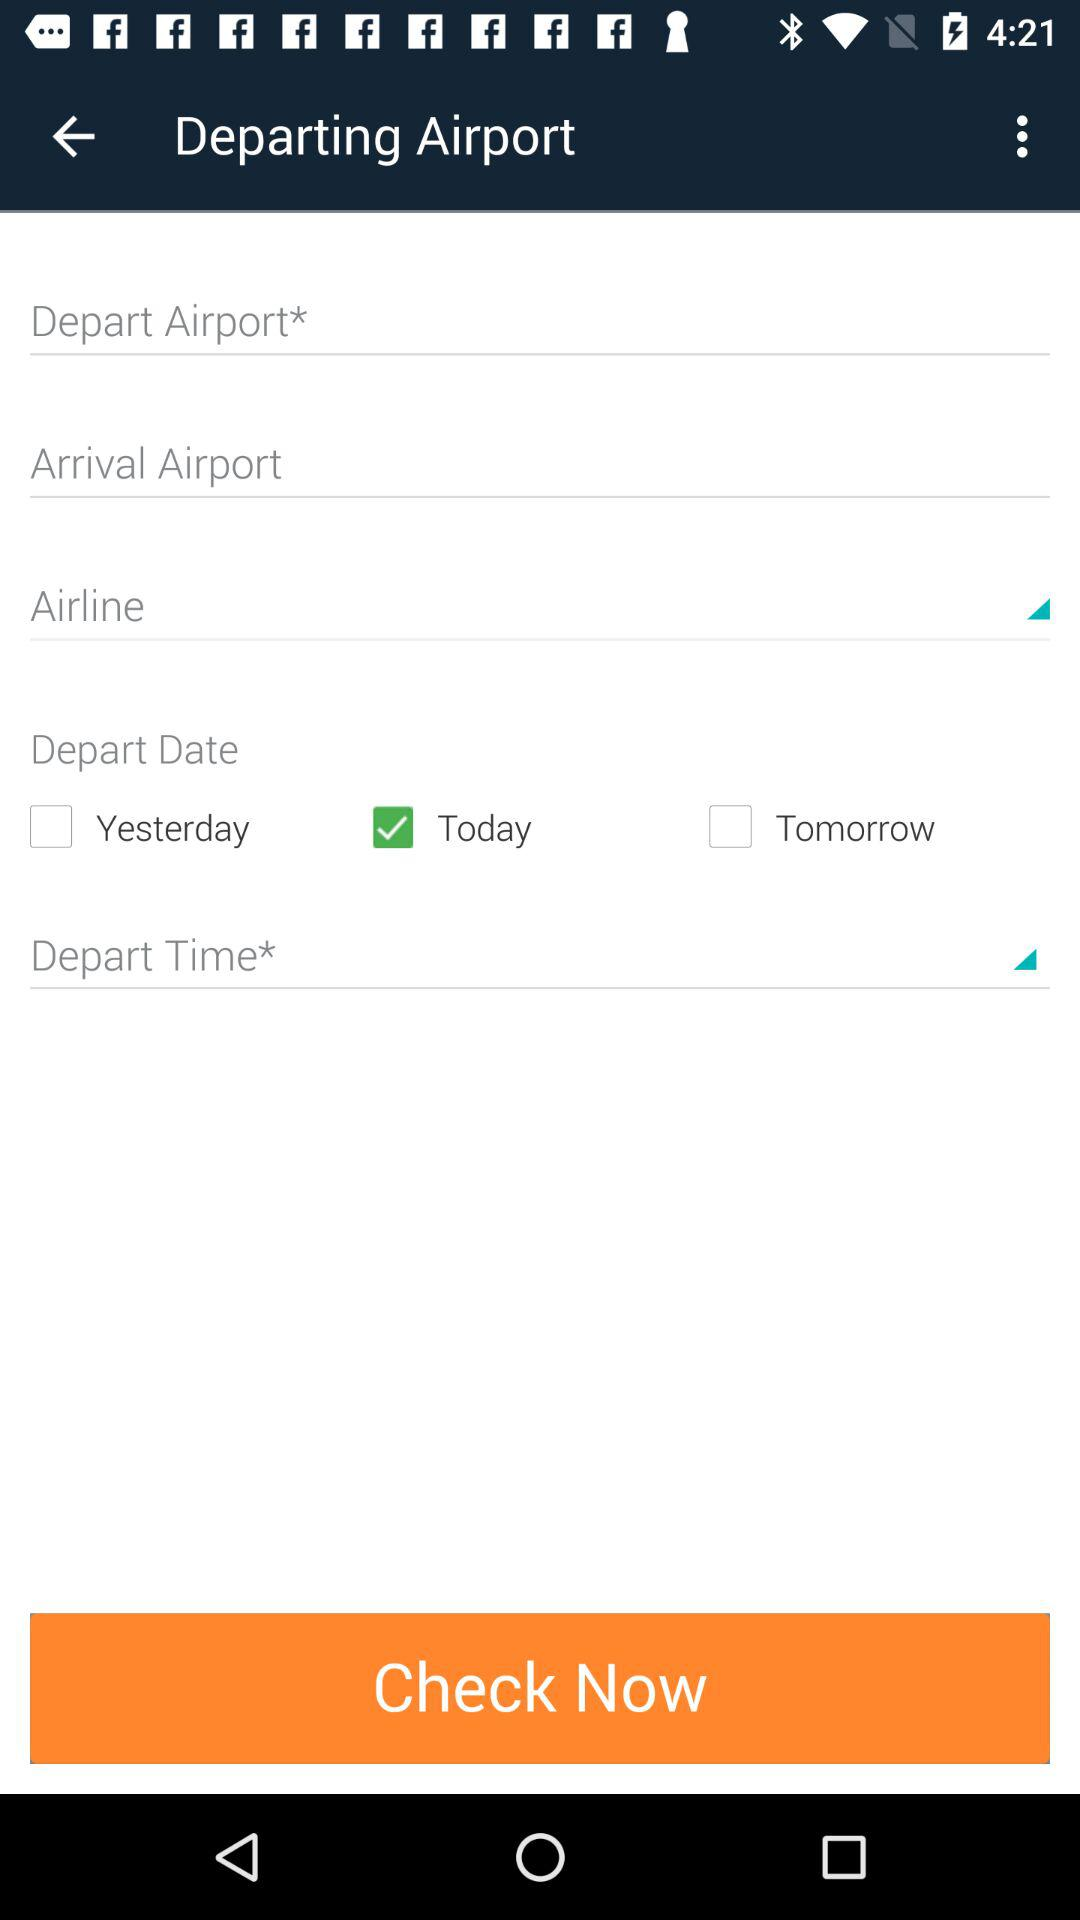How many options are available for the departure date?
Answer the question using a single word or phrase. 3 